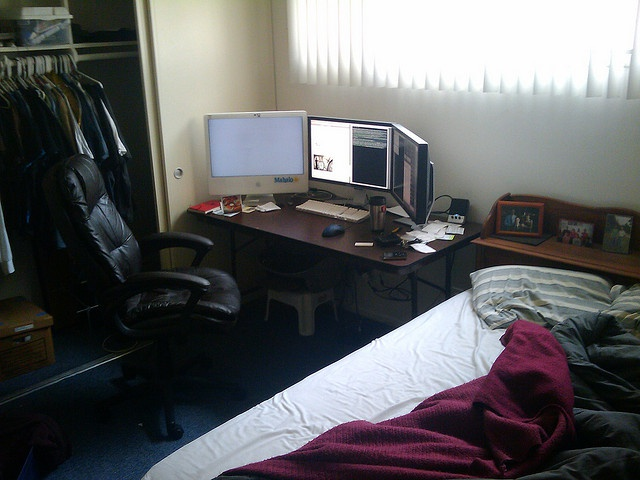Describe the objects in this image and their specific colors. I can see bed in darkgreen, black, lavender, darkgray, and purple tones, chair in darkgreen, black, gray, and blue tones, tv in darkgreen, darkgray, and gray tones, tv in darkgreen, white, black, darkgray, and gray tones, and tv in darkgreen, black, and gray tones in this image. 